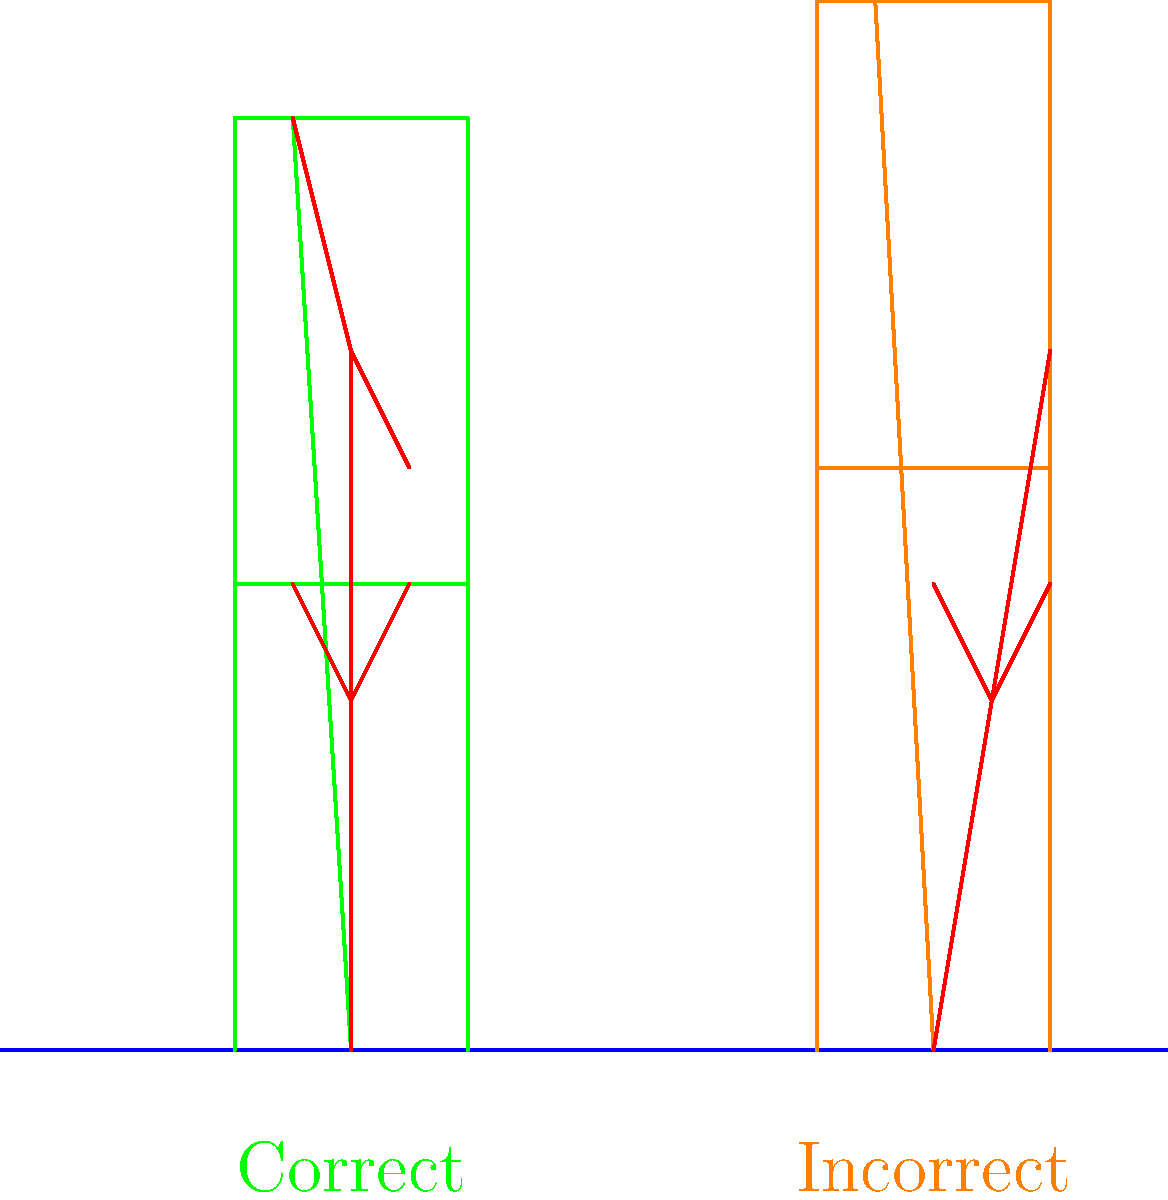Analyze the ergonomics of the two easel setups shown in the diagram. Which setup promotes better posture for the artist, and why? To determine which easel setup promotes better posture, let's analyze both setups step-by-step:

1. Left setup (green easel):
   a) The artist's spine is relatively straight and aligned.
   b) The arms are at a comfortable angle, not overextended.
   c) The head is in a neutral position, not tilted excessively.
   d) The easel is tilted slightly, allowing for a more natural viewing angle.

2. Right setup (orange easel):
   a) The artist's spine is curved, creating an unnatural "C" shape.
   b) The arms are extended upwards, which can cause shoulder strain.
   c) The head is tilted back, potentially leading to neck strain.
   d) The easel is completely vertical, requiring the artist to look up constantly.

3. Ergonomic principles:
   a) Neutral spine alignment reduces the risk of back pain and injury.
   b) Keeping arms closer to the body reduces shoulder and upper back strain.
   c) Maintaining a neutral head position prevents neck strain.
   d) Proper easel angle reduces the need for excessive head tilting.

4. Impact on the artist:
   a) The left setup allows for longer, more comfortable working sessions.
   b) The right setup may lead to fatigue, pain, and potential long-term injuries.

Therefore, the left setup (green easel) promotes better posture for the artist by maintaining proper spine alignment, reducing strain on the arms and neck, and providing a more ergonomic working angle.
Answer: Left setup (green easel) 